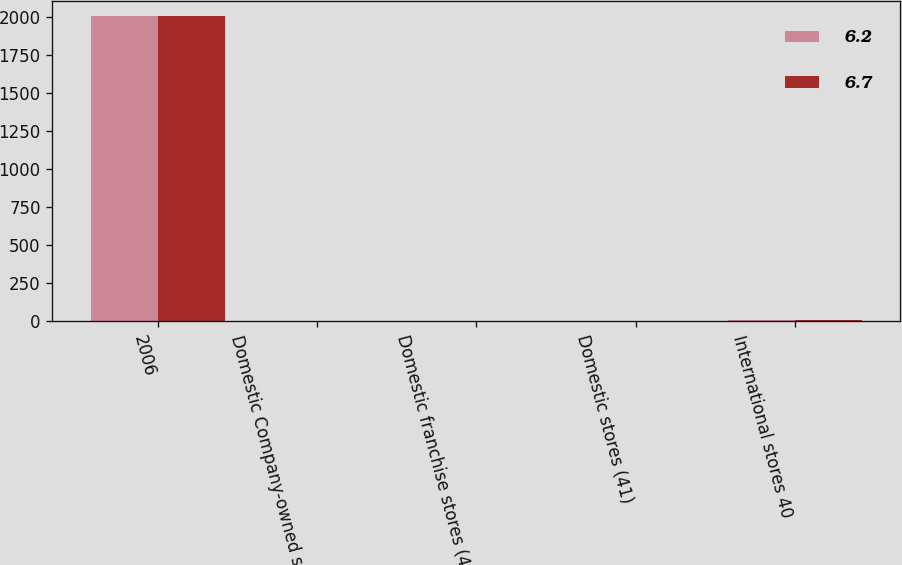<chart> <loc_0><loc_0><loc_500><loc_500><stacked_bar_chart><ecel><fcel>2006<fcel>Domestic Company-owned stores<fcel>Domestic franchise stores (44)<fcel>Domestic stores (41)<fcel>International stores 40<nl><fcel>6.2<fcel>2007<fcel>1<fcel>2.1<fcel>1.7<fcel>6.7<nl><fcel>6.7<fcel>2008<fcel>2.2<fcel>5.2<fcel>4.9<fcel>6.2<nl></chart> 